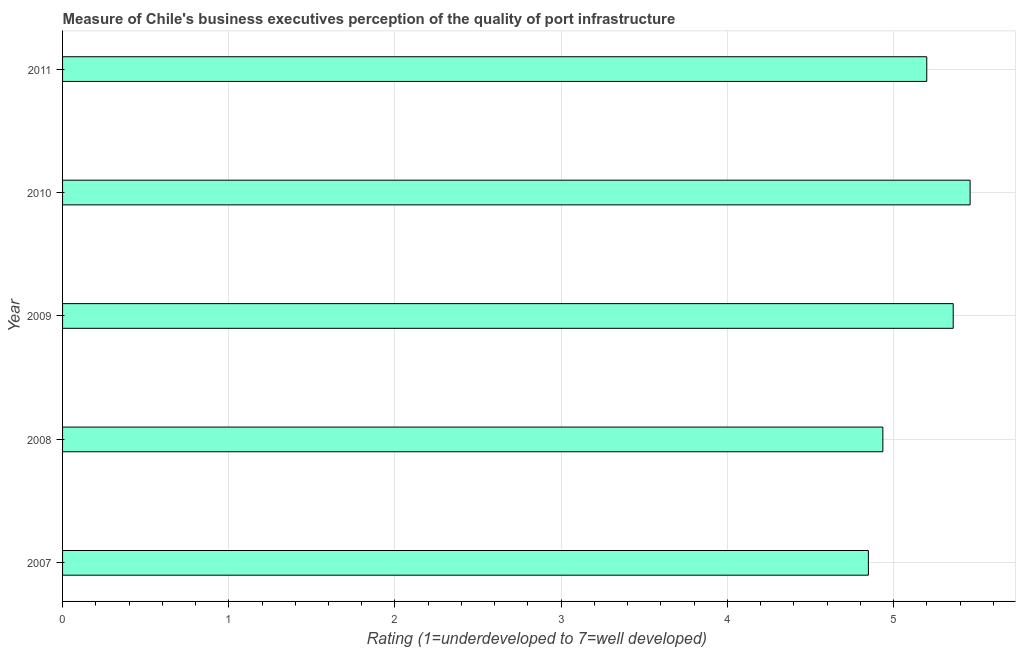Does the graph contain any zero values?
Provide a succinct answer. No. Does the graph contain grids?
Ensure brevity in your answer.  Yes. What is the title of the graph?
Provide a succinct answer. Measure of Chile's business executives perception of the quality of port infrastructure. What is the label or title of the X-axis?
Your response must be concise. Rating (1=underdeveloped to 7=well developed) . What is the rating measuring quality of port infrastructure in 2011?
Make the answer very short. 5.2. Across all years, what is the maximum rating measuring quality of port infrastructure?
Make the answer very short. 5.46. Across all years, what is the minimum rating measuring quality of port infrastructure?
Keep it short and to the point. 4.85. In which year was the rating measuring quality of port infrastructure minimum?
Your answer should be compact. 2007. What is the sum of the rating measuring quality of port infrastructure?
Offer a very short reply. 25.8. What is the difference between the rating measuring quality of port infrastructure in 2007 and 2010?
Make the answer very short. -0.61. What is the average rating measuring quality of port infrastructure per year?
Ensure brevity in your answer.  5.16. What is the median rating measuring quality of port infrastructure?
Provide a short and direct response. 5.2. What is the ratio of the rating measuring quality of port infrastructure in 2008 to that in 2010?
Make the answer very short. 0.9. What is the difference between the highest and the second highest rating measuring quality of port infrastructure?
Offer a terse response. 0.1. What is the difference between the highest and the lowest rating measuring quality of port infrastructure?
Offer a very short reply. 0.61. In how many years, is the rating measuring quality of port infrastructure greater than the average rating measuring quality of port infrastructure taken over all years?
Provide a short and direct response. 3. Are all the bars in the graph horizontal?
Provide a short and direct response. Yes. What is the Rating (1=underdeveloped to 7=well developed)  of 2007?
Keep it short and to the point. 4.85. What is the Rating (1=underdeveloped to 7=well developed)  of 2008?
Provide a short and direct response. 4.94. What is the Rating (1=underdeveloped to 7=well developed)  in 2009?
Your response must be concise. 5.36. What is the Rating (1=underdeveloped to 7=well developed)  in 2010?
Give a very brief answer. 5.46. What is the difference between the Rating (1=underdeveloped to 7=well developed)  in 2007 and 2008?
Give a very brief answer. -0.09. What is the difference between the Rating (1=underdeveloped to 7=well developed)  in 2007 and 2009?
Offer a terse response. -0.51. What is the difference between the Rating (1=underdeveloped to 7=well developed)  in 2007 and 2010?
Offer a terse response. -0.61. What is the difference between the Rating (1=underdeveloped to 7=well developed)  in 2007 and 2011?
Make the answer very short. -0.35. What is the difference between the Rating (1=underdeveloped to 7=well developed)  in 2008 and 2009?
Provide a short and direct response. -0.42. What is the difference between the Rating (1=underdeveloped to 7=well developed)  in 2008 and 2010?
Offer a terse response. -0.52. What is the difference between the Rating (1=underdeveloped to 7=well developed)  in 2008 and 2011?
Offer a very short reply. -0.26. What is the difference between the Rating (1=underdeveloped to 7=well developed)  in 2009 and 2010?
Provide a short and direct response. -0.1. What is the difference between the Rating (1=underdeveloped to 7=well developed)  in 2009 and 2011?
Provide a short and direct response. 0.16. What is the difference between the Rating (1=underdeveloped to 7=well developed)  in 2010 and 2011?
Give a very brief answer. 0.26. What is the ratio of the Rating (1=underdeveloped to 7=well developed)  in 2007 to that in 2009?
Keep it short and to the point. 0.91. What is the ratio of the Rating (1=underdeveloped to 7=well developed)  in 2007 to that in 2010?
Keep it short and to the point. 0.89. What is the ratio of the Rating (1=underdeveloped to 7=well developed)  in 2007 to that in 2011?
Your answer should be very brief. 0.93. What is the ratio of the Rating (1=underdeveloped to 7=well developed)  in 2008 to that in 2009?
Your answer should be very brief. 0.92. What is the ratio of the Rating (1=underdeveloped to 7=well developed)  in 2008 to that in 2010?
Keep it short and to the point. 0.9. What is the ratio of the Rating (1=underdeveloped to 7=well developed)  in 2008 to that in 2011?
Keep it short and to the point. 0.95. What is the ratio of the Rating (1=underdeveloped to 7=well developed)  in 2009 to that in 2010?
Provide a succinct answer. 0.98. What is the ratio of the Rating (1=underdeveloped to 7=well developed)  in 2009 to that in 2011?
Your answer should be compact. 1.03. What is the ratio of the Rating (1=underdeveloped to 7=well developed)  in 2010 to that in 2011?
Ensure brevity in your answer.  1.05. 